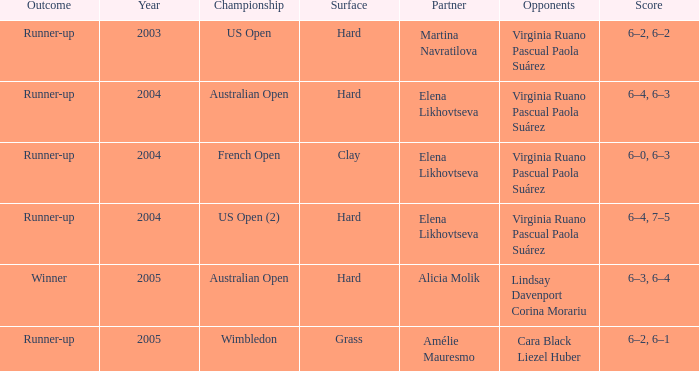What type of surface is used in the us open (2) championship? Hard. 